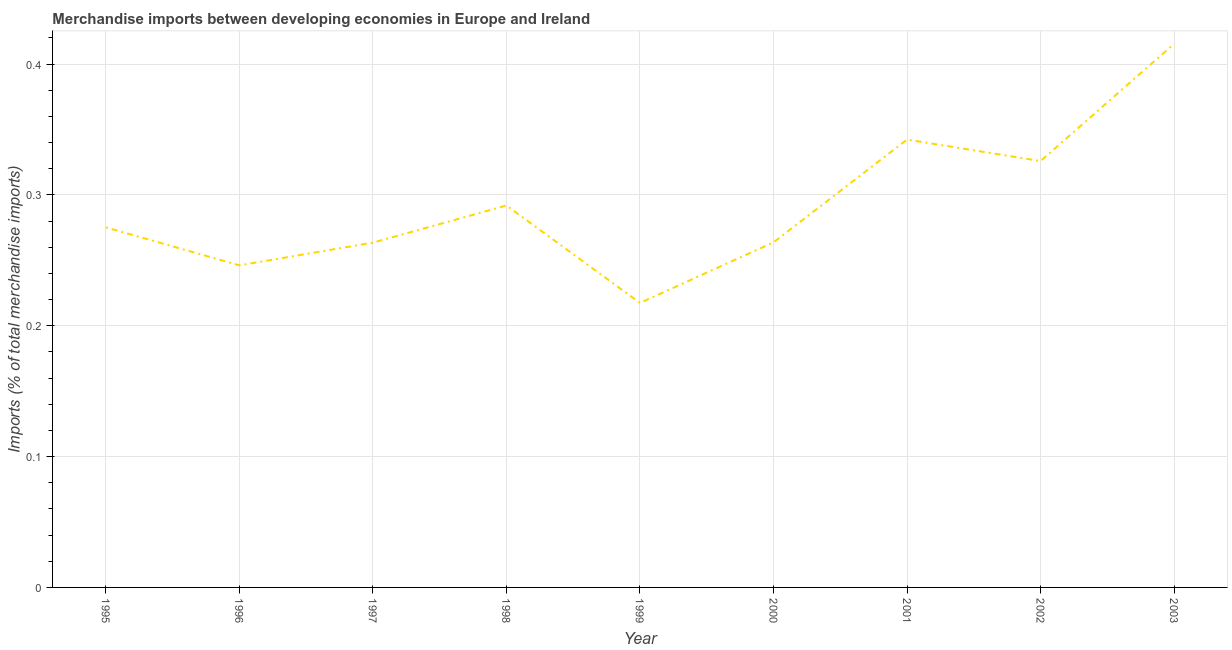What is the merchandise imports in 1999?
Give a very brief answer. 0.22. Across all years, what is the maximum merchandise imports?
Keep it short and to the point. 0.42. Across all years, what is the minimum merchandise imports?
Your answer should be very brief. 0.22. In which year was the merchandise imports minimum?
Offer a terse response. 1999. What is the sum of the merchandise imports?
Your answer should be compact. 2.64. What is the difference between the merchandise imports in 2001 and 2003?
Provide a short and direct response. -0.07. What is the average merchandise imports per year?
Give a very brief answer. 0.29. What is the median merchandise imports?
Make the answer very short. 0.28. Do a majority of the years between 1996 and 2003 (inclusive) have merchandise imports greater than 0.22 %?
Ensure brevity in your answer.  Yes. What is the ratio of the merchandise imports in 1998 to that in 2001?
Give a very brief answer. 0.85. Is the merchandise imports in 2001 less than that in 2002?
Keep it short and to the point. No. Is the difference between the merchandise imports in 1997 and 2001 greater than the difference between any two years?
Keep it short and to the point. No. What is the difference between the highest and the second highest merchandise imports?
Keep it short and to the point. 0.07. What is the difference between the highest and the lowest merchandise imports?
Keep it short and to the point. 0.2. Does the merchandise imports monotonically increase over the years?
Make the answer very short. No. How many lines are there?
Your response must be concise. 1. How many years are there in the graph?
Keep it short and to the point. 9. What is the difference between two consecutive major ticks on the Y-axis?
Ensure brevity in your answer.  0.1. Does the graph contain grids?
Your answer should be very brief. Yes. What is the title of the graph?
Keep it short and to the point. Merchandise imports between developing economies in Europe and Ireland. What is the label or title of the X-axis?
Ensure brevity in your answer.  Year. What is the label or title of the Y-axis?
Provide a succinct answer. Imports (% of total merchandise imports). What is the Imports (% of total merchandise imports) in 1995?
Provide a short and direct response. 0.28. What is the Imports (% of total merchandise imports) of 1996?
Give a very brief answer. 0.25. What is the Imports (% of total merchandise imports) of 1997?
Provide a short and direct response. 0.26. What is the Imports (% of total merchandise imports) of 1998?
Keep it short and to the point. 0.29. What is the Imports (% of total merchandise imports) in 1999?
Your response must be concise. 0.22. What is the Imports (% of total merchandise imports) of 2000?
Your response must be concise. 0.26. What is the Imports (% of total merchandise imports) in 2001?
Provide a succinct answer. 0.34. What is the Imports (% of total merchandise imports) of 2002?
Keep it short and to the point. 0.33. What is the Imports (% of total merchandise imports) in 2003?
Your response must be concise. 0.42. What is the difference between the Imports (% of total merchandise imports) in 1995 and 1996?
Provide a short and direct response. 0.03. What is the difference between the Imports (% of total merchandise imports) in 1995 and 1997?
Provide a succinct answer. 0.01. What is the difference between the Imports (% of total merchandise imports) in 1995 and 1998?
Keep it short and to the point. -0.02. What is the difference between the Imports (% of total merchandise imports) in 1995 and 1999?
Ensure brevity in your answer.  0.06. What is the difference between the Imports (% of total merchandise imports) in 1995 and 2000?
Provide a succinct answer. 0.01. What is the difference between the Imports (% of total merchandise imports) in 1995 and 2001?
Your answer should be very brief. -0.07. What is the difference between the Imports (% of total merchandise imports) in 1995 and 2002?
Offer a very short reply. -0.05. What is the difference between the Imports (% of total merchandise imports) in 1995 and 2003?
Make the answer very short. -0.14. What is the difference between the Imports (% of total merchandise imports) in 1996 and 1997?
Your response must be concise. -0.02. What is the difference between the Imports (% of total merchandise imports) in 1996 and 1998?
Make the answer very short. -0.05. What is the difference between the Imports (% of total merchandise imports) in 1996 and 1999?
Give a very brief answer. 0.03. What is the difference between the Imports (% of total merchandise imports) in 1996 and 2000?
Your answer should be very brief. -0.02. What is the difference between the Imports (% of total merchandise imports) in 1996 and 2001?
Offer a terse response. -0.1. What is the difference between the Imports (% of total merchandise imports) in 1996 and 2002?
Keep it short and to the point. -0.08. What is the difference between the Imports (% of total merchandise imports) in 1996 and 2003?
Your answer should be compact. -0.17. What is the difference between the Imports (% of total merchandise imports) in 1997 and 1998?
Offer a very short reply. -0.03. What is the difference between the Imports (% of total merchandise imports) in 1997 and 1999?
Offer a terse response. 0.05. What is the difference between the Imports (% of total merchandise imports) in 1997 and 2000?
Provide a succinct answer. -0. What is the difference between the Imports (% of total merchandise imports) in 1997 and 2001?
Offer a terse response. -0.08. What is the difference between the Imports (% of total merchandise imports) in 1997 and 2002?
Your answer should be very brief. -0.06. What is the difference between the Imports (% of total merchandise imports) in 1997 and 2003?
Make the answer very short. -0.15. What is the difference between the Imports (% of total merchandise imports) in 1998 and 1999?
Provide a succinct answer. 0.07. What is the difference between the Imports (% of total merchandise imports) in 1998 and 2000?
Offer a terse response. 0.03. What is the difference between the Imports (% of total merchandise imports) in 1998 and 2001?
Offer a terse response. -0.05. What is the difference between the Imports (% of total merchandise imports) in 1998 and 2002?
Keep it short and to the point. -0.03. What is the difference between the Imports (% of total merchandise imports) in 1998 and 2003?
Provide a succinct answer. -0.12. What is the difference between the Imports (% of total merchandise imports) in 1999 and 2000?
Offer a very short reply. -0.05. What is the difference between the Imports (% of total merchandise imports) in 1999 and 2001?
Keep it short and to the point. -0.12. What is the difference between the Imports (% of total merchandise imports) in 1999 and 2002?
Offer a very short reply. -0.11. What is the difference between the Imports (% of total merchandise imports) in 1999 and 2003?
Provide a short and direct response. -0.2. What is the difference between the Imports (% of total merchandise imports) in 2000 and 2001?
Your answer should be very brief. -0.08. What is the difference between the Imports (% of total merchandise imports) in 2000 and 2002?
Your answer should be compact. -0.06. What is the difference between the Imports (% of total merchandise imports) in 2000 and 2003?
Give a very brief answer. -0.15. What is the difference between the Imports (% of total merchandise imports) in 2001 and 2002?
Make the answer very short. 0.02. What is the difference between the Imports (% of total merchandise imports) in 2001 and 2003?
Ensure brevity in your answer.  -0.07. What is the difference between the Imports (% of total merchandise imports) in 2002 and 2003?
Your response must be concise. -0.09. What is the ratio of the Imports (% of total merchandise imports) in 1995 to that in 1996?
Provide a succinct answer. 1.12. What is the ratio of the Imports (% of total merchandise imports) in 1995 to that in 1997?
Your answer should be very brief. 1.04. What is the ratio of the Imports (% of total merchandise imports) in 1995 to that in 1998?
Offer a very short reply. 0.94. What is the ratio of the Imports (% of total merchandise imports) in 1995 to that in 1999?
Your response must be concise. 1.27. What is the ratio of the Imports (% of total merchandise imports) in 1995 to that in 2000?
Make the answer very short. 1.04. What is the ratio of the Imports (% of total merchandise imports) in 1995 to that in 2001?
Your answer should be very brief. 0.8. What is the ratio of the Imports (% of total merchandise imports) in 1995 to that in 2002?
Keep it short and to the point. 0.84. What is the ratio of the Imports (% of total merchandise imports) in 1995 to that in 2003?
Offer a very short reply. 0.66. What is the ratio of the Imports (% of total merchandise imports) in 1996 to that in 1997?
Your response must be concise. 0.93. What is the ratio of the Imports (% of total merchandise imports) in 1996 to that in 1998?
Provide a succinct answer. 0.84. What is the ratio of the Imports (% of total merchandise imports) in 1996 to that in 1999?
Your response must be concise. 1.13. What is the ratio of the Imports (% of total merchandise imports) in 1996 to that in 2000?
Provide a succinct answer. 0.93. What is the ratio of the Imports (% of total merchandise imports) in 1996 to that in 2001?
Give a very brief answer. 0.72. What is the ratio of the Imports (% of total merchandise imports) in 1996 to that in 2002?
Offer a terse response. 0.76. What is the ratio of the Imports (% of total merchandise imports) in 1996 to that in 2003?
Ensure brevity in your answer.  0.59. What is the ratio of the Imports (% of total merchandise imports) in 1997 to that in 1998?
Your response must be concise. 0.9. What is the ratio of the Imports (% of total merchandise imports) in 1997 to that in 1999?
Your response must be concise. 1.21. What is the ratio of the Imports (% of total merchandise imports) in 1997 to that in 2001?
Keep it short and to the point. 0.77. What is the ratio of the Imports (% of total merchandise imports) in 1997 to that in 2002?
Your response must be concise. 0.81. What is the ratio of the Imports (% of total merchandise imports) in 1997 to that in 2003?
Provide a short and direct response. 0.63. What is the ratio of the Imports (% of total merchandise imports) in 1998 to that in 1999?
Provide a succinct answer. 1.34. What is the ratio of the Imports (% of total merchandise imports) in 1998 to that in 2000?
Provide a succinct answer. 1.11. What is the ratio of the Imports (% of total merchandise imports) in 1998 to that in 2001?
Provide a short and direct response. 0.85. What is the ratio of the Imports (% of total merchandise imports) in 1998 to that in 2002?
Provide a succinct answer. 0.9. What is the ratio of the Imports (% of total merchandise imports) in 1998 to that in 2003?
Offer a terse response. 0.7. What is the ratio of the Imports (% of total merchandise imports) in 1999 to that in 2000?
Make the answer very short. 0.82. What is the ratio of the Imports (% of total merchandise imports) in 1999 to that in 2001?
Make the answer very short. 0.64. What is the ratio of the Imports (% of total merchandise imports) in 1999 to that in 2002?
Keep it short and to the point. 0.67. What is the ratio of the Imports (% of total merchandise imports) in 1999 to that in 2003?
Your answer should be very brief. 0.52. What is the ratio of the Imports (% of total merchandise imports) in 2000 to that in 2001?
Keep it short and to the point. 0.77. What is the ratio of the Imports (% of total merchandise imports) in 2000 to that in 2002?
Ensure brevity in your answer.  0.81. What is the ratio of the Imports (% of total merchandise imports) in 2000 to that in 2003?
Give a very brief answer. 0.64. What is the ratio of the Imports (% of total merchandise imports) in 2001 to that in 2003?
Make the answer very short. 0.82. What is the ratio of the Imports (% of total merchandise imports) in 2002 to that in 2003?
Give a very brief answer. 0.78. 